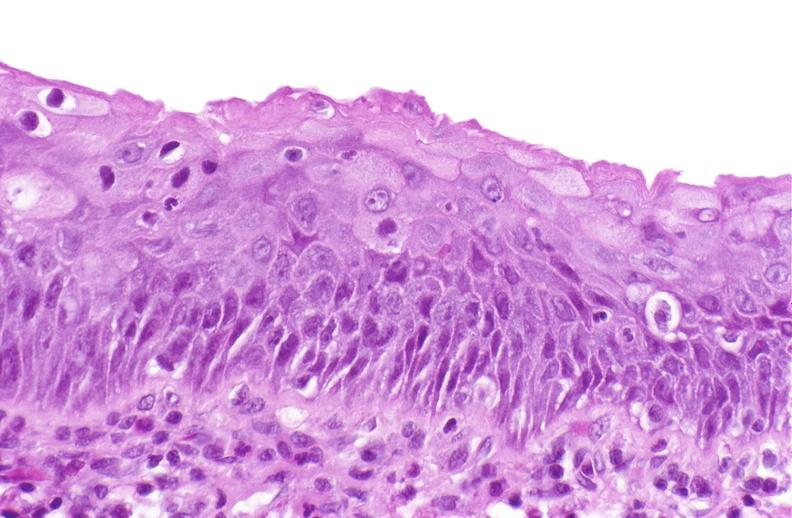what does this image show?
Answer the question using a single word or phrase. Squamous metaplasia 